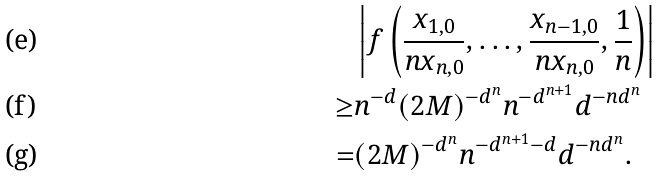<formula> <loc_0><loc_0><loc_500><loc_500>& \left | f \left ( \frac { x _ { 1 , 0 } } { n x _ { n , 0 } } , \dots , \frac { x _ { n - 1 , 0 } } { n x _ { n , 0 } } , \frac { 1 } { n } \right ) \right | \\ \geq & n ^ { - d } ( 2 M ) ^ { - d ^ { n } } n ^ { - d ^ { n + 1 } } d ^ { - n d ^ { n } } \\ = & ( 2 M ) ^ { - d ^ { n } } n ^ { - d ^ { n + 1 } - d } d ^ { - n d ^ { n } } .</formula> 